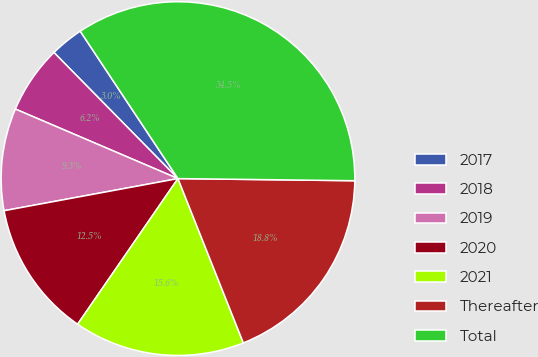Convert chart. <chart><loc_0><loc_0><loc_500><loc_500><pie_chart><fcel>2017<fcel>2018<fcel>2019<fcel>2020<fcel>2021<fcel>Thereafter<fcel>Total<nl><fcel>3.05%<fcel>6.2%<fcel>9.34%<fcel>12.49%<fcel>15.63%<fcel>18.78%<fcel>34.51%<nl></chart> 